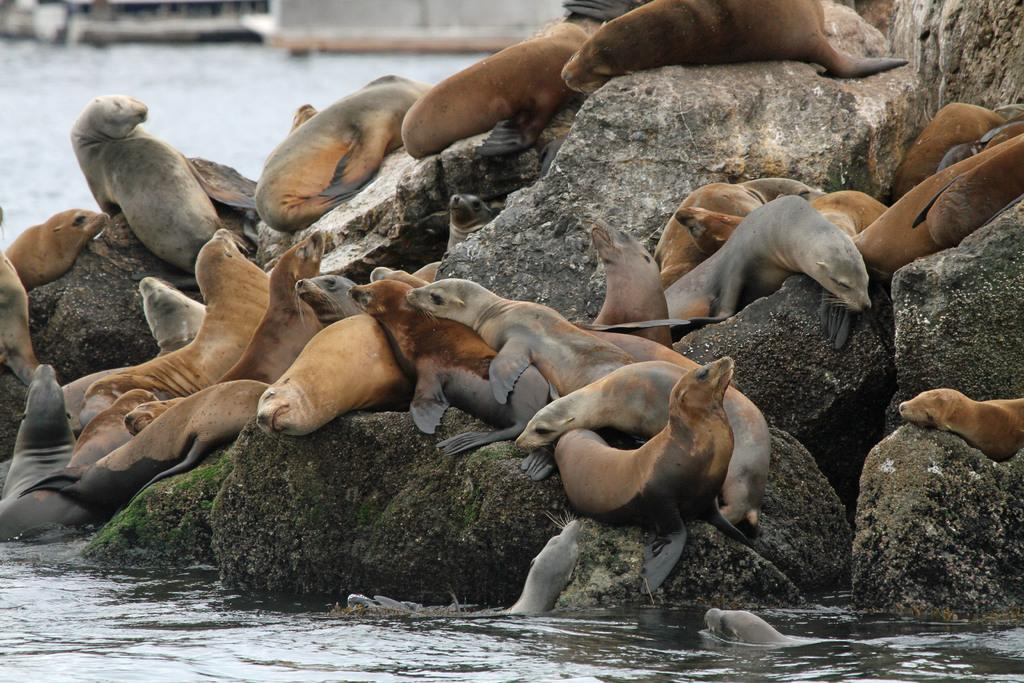What animals can be seen on the rocks in the image? There are sea lions on the rocks in the image. What natural element is visible in the image? There is water visible in the image. Can you describe the background of the image? The background of the image is blurry. What type of knife is being used to reason with the sea lions in the image? There is no knife or reasoning with the sea lions in the image; they are simply resting on the rocks. 